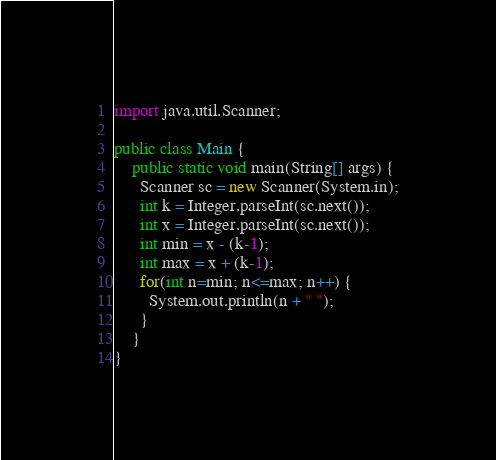<code> <loc_0><loc_0><loc_500><loc_500><_Java_>import java.util.Scanner;

public class Main {
	public static void main(String[] args) {
      Scanner sc = new Scanner(System.in);
      int k = Integer.parseInt(sc.next());
      int x = Integer.parseInt(sc.next());
      int min = x - (k-1);
      int max = x + (k-1);
      for(int n=min; n<=max; n++) {
      	System.out.println(n + " ");
      }
    }
}</code> 